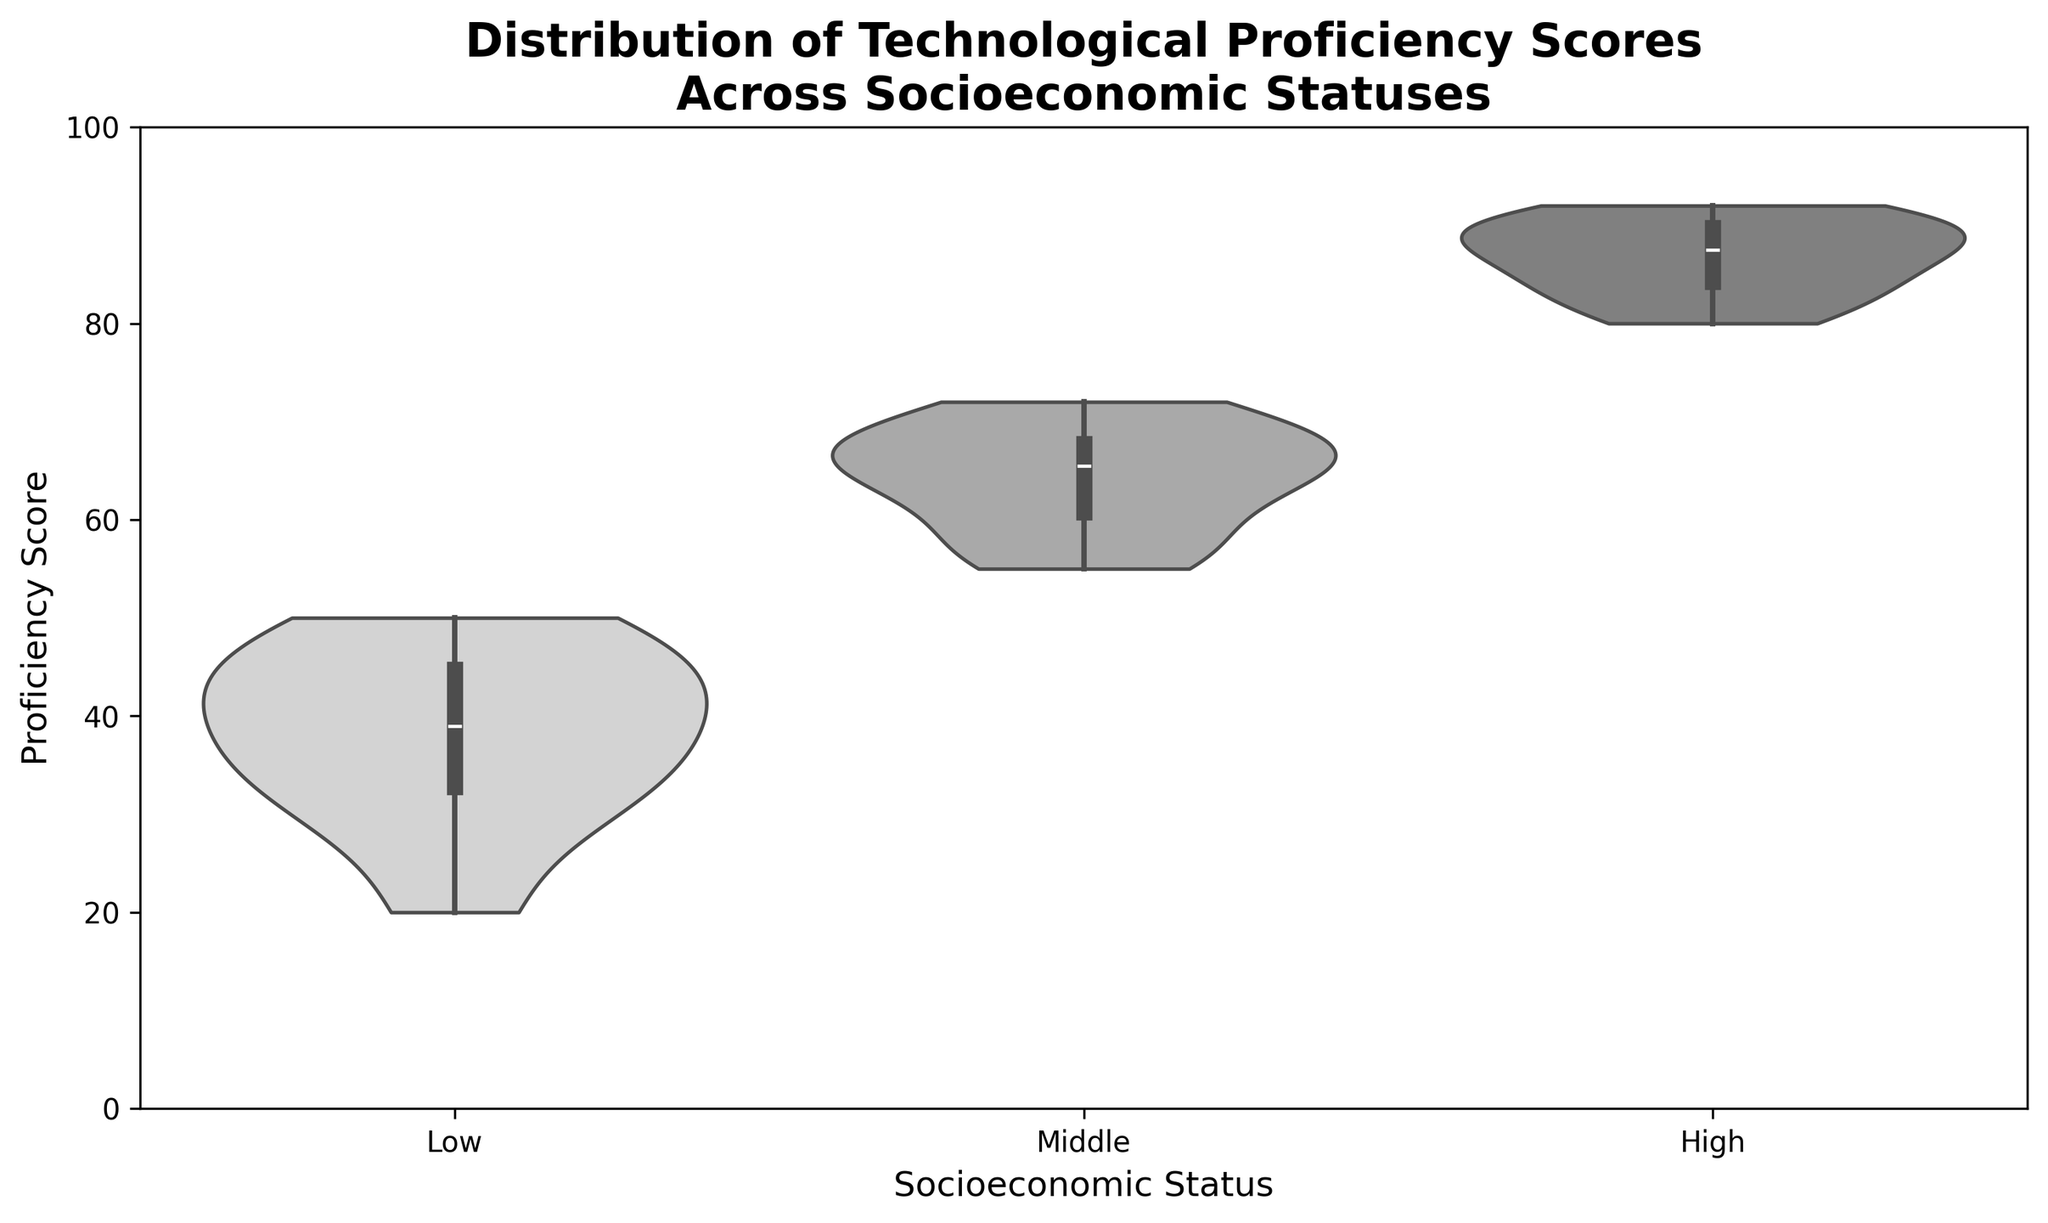What's the title of the figure? The title is clearly displayed at the top of the figure. The full title is "Distribution of Technological Proficiency Scores Across Socioeconomic Statuses"
Answer: Distribution of Technological Proficiency Scores Across Socioeconomic Statuses What are the labels for the x and y axes? The x-axis label is found below the horizontal axis, and the y-axis label is found next to the vertical axis. The x-axis label is "Socioeconomic Status," and the y-axis label is "Proficiency Score."
Answer: Socioeconomic Status; Proficiency Score Which socioeconomic status group shows the highest median proficiency score? The median is represented by the white dot inside the violin plot. For the High socioeconomic status group, the median white dot is at the highest proficiency score.
Answer: High Are the proficiency scores more spread out in the Low or High socioeconomic status group? The spread of scores can be assessed by the width of the violin plot. The Low socioeconomic status group has a wider distribution indicating more spread-out scores compared to the High group.
Answer: Low What is the range of proficiency scores for the Middle socioeconomic status group? The range can be determined by the extent of the violin plot. For the Middle socioeconomic status group, the scores range approximately from 55 to 72.
Answer: 55 to 72 Compare the interquartile range (IQR) for Low and High socioeconomic status groups. Which one is larger? The IQR refers to the spread between the 25th and 75th percentiles, visible as the thicker part of the violin. By visual comparison, the Low group has a broader thicker part compared to the High group.
Answer: Low What is the primary color scheme used in the figure? The figure is in grayscale, with varying shades of gray for different socioeconomic status groups. This is evident from the palette of colors used to fill the violin plots.
Answer: Grayscale How many distinct groups are represented in the figure? The number of groups can be determined by counting the different categories on the x-axis. There are three distinct groups: Low, Middle, and High.
Answer: Three Is the lowest proficiency score higher in the Middle socioeconomic status group or the Low socioeconomic status group? The lowest score is indicated by the lower end of the violin plot. The Middle socioeconomic status group has a higher bottom end compared to the Low group.
Answer: Middle By observing the spread and peaks of the violin plots, which socioeconomic status group seems to have the most consistent proficiency scores? Consistency is indicated by a narrow spread and well-defined peak. The High socioeconomic status group has the narrowest spread and the peak is most concentrated, suggesting the highest consistency.
Answer: High 